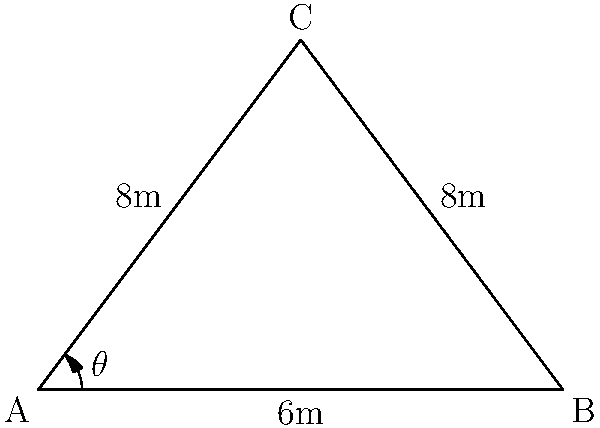At the premiere of Suraj Venjaramoodu's latest film, two spotlights are illuminating a movie poster from different angles. The spotlights are placed 6 meters apart, and each is 8 meters away from the center of the poster. What is the angle $\theta$ between the two spotlights? Let's approach this step-by-step:

1) The scenario forms an isosceles triangle, where:
   - The base of the triangle is the distance between the spotlights (6m)
   - The two equal sides are the distances from each spotlight to the poster (8m)

2) We can split this isosceles triangle into two right triangles by drawing a line from the top vertex to the midpoint of the base.

3) In one of these right triangles:
   - The hypotenuse is 8m
   - Half of the base is 3m (6m ÷ 2)

4) We can use the cosine function to find half of our desired angle:

   $\cos(\frac{\theta}{2}) = \frac{\text{adjacent}}{\text{hypotenuse}} = \frac{3}{8}$

5) To solve for $\frac{\theta}{2}$, we take the inverse cosine (arccos) of both sides:

   $\frac{\theta}{2} = \arccos(\frac{3}{8})$

6) To get $\theta$, we multiply both sides by 2:

   $\theta = 2 \arccos(\frac{3}{8})$

7) Using a calculator or computer, we can evaluate this:

   $\theta \approx 2 * 0.9272952180 = 1.8545904361$ radians

8) Converting to degrees:

   $\theta \approx 1.8545904361 * \frac{180}{\pi} \approx 106.26°$
Answer: $106.26°$ 